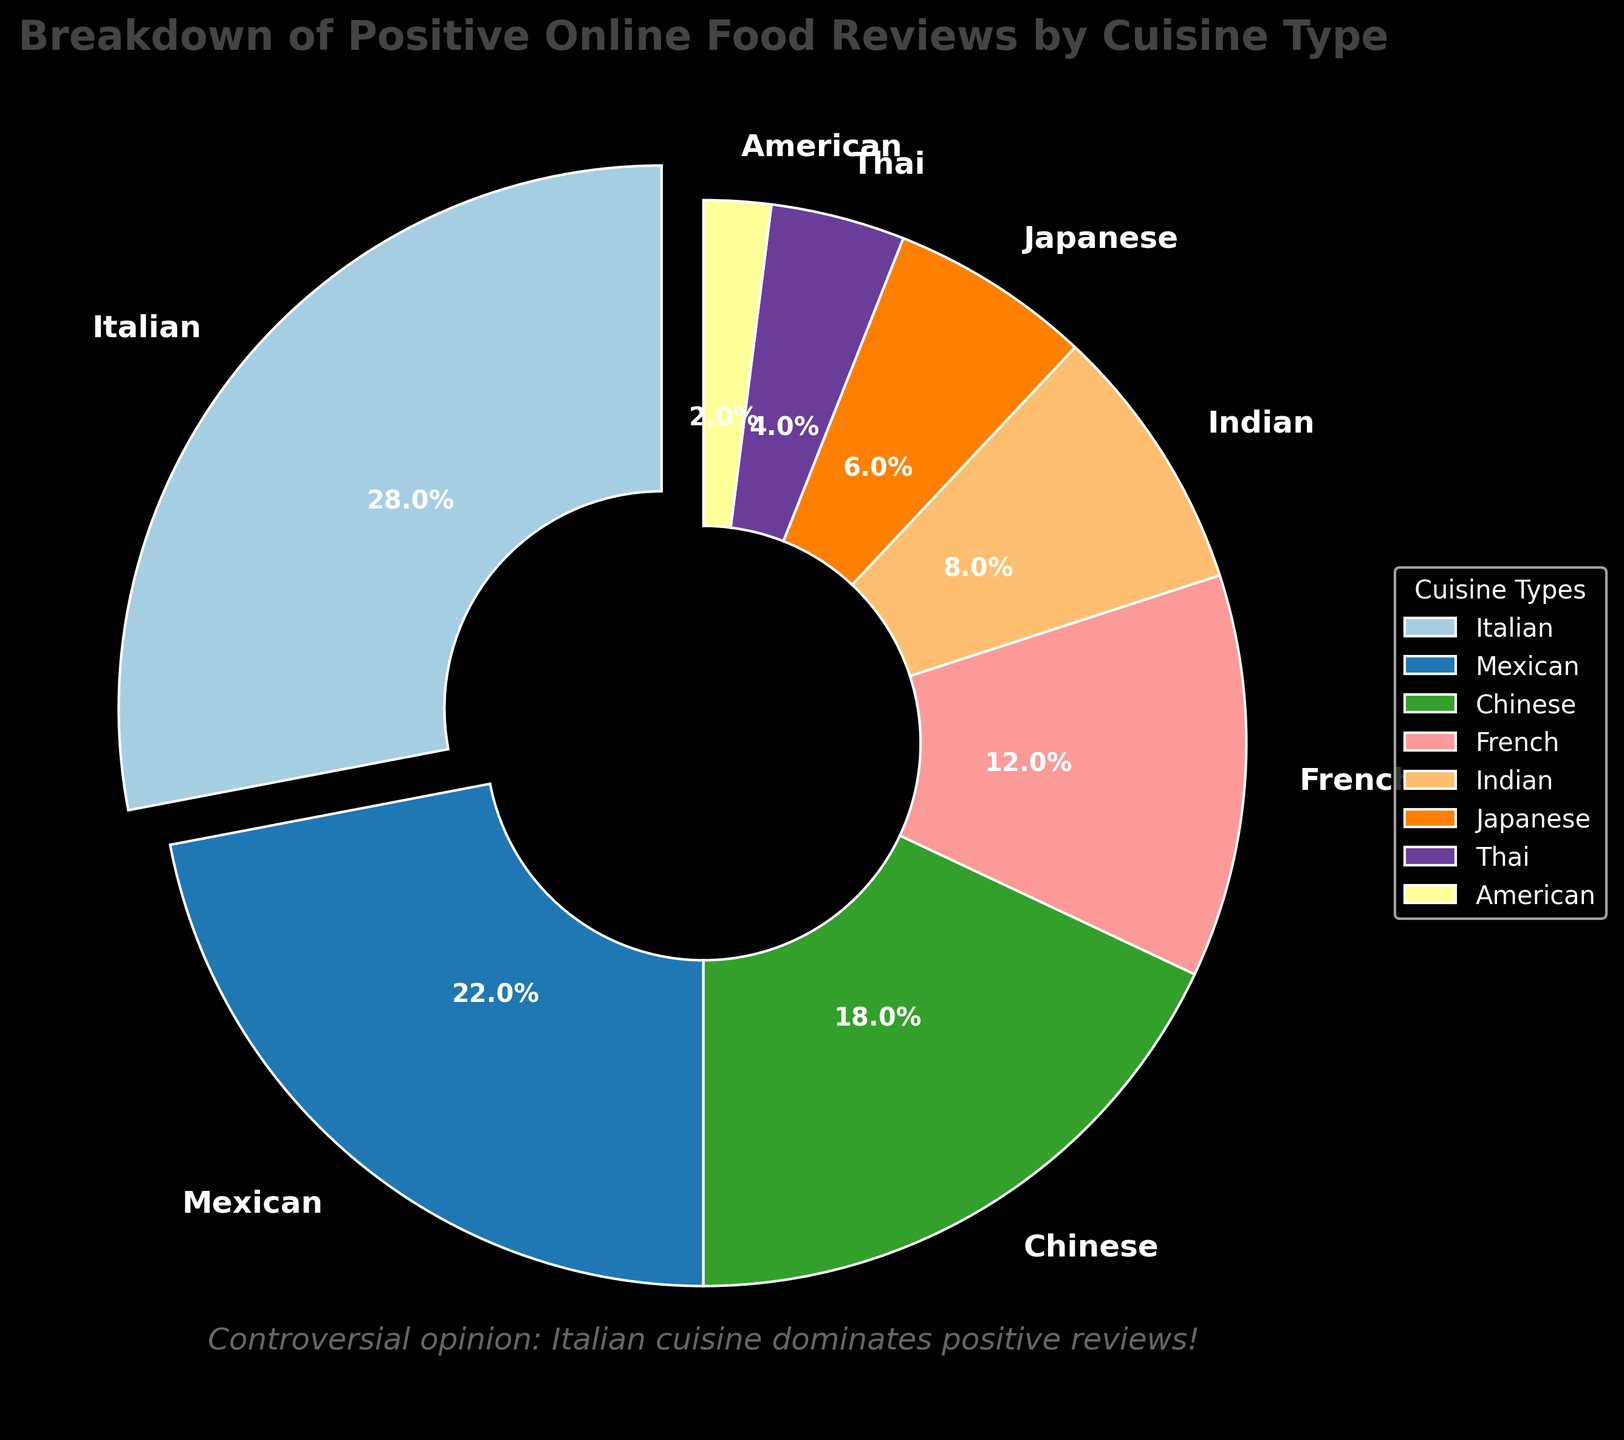Which cuisine has the highest percentage of positive reviews? The cuisine with the highest percentage is marked by an exploded wedge and annotated with the highest number. This is visually clear in the figure.
Answer: Italian Which cuisines have less than 10% of positive reviews each? To identify these cuisines, check the wedges with percentages less than 10% on the pie chart. The annotations show the percentages clearly.
Answer: Indian, Japanese, Thai, American What is the combined percentage of positive reviews for Mexican and Chinese cuisines? Add the percentages for Mexican (22%) and Chinese (18%) cuisines. 22 + 18 = 40.
Answer: 40% How much more is the percentage of positive reviews for Italian cuisine compared to French cuisine? Subtract the percentage for French (12%) from the percentage for Italian (28%). 28 - 12 = 16.
Answer: 16% Which cuisine has the smallest percentage of positive reviews and what is it? The smallest wedge with the smallest percentage annotation corresponds to the cuisine with the least positive reviews.
Answer: American, 2% Rank the cuisines from most to least positive reviews. Arrange the cuisines by descending order of their percentages as shown on the chart.
Answer: Italian, Mexican, Chinese, French, Indian, Japanese, Thai, American What percentage of positive reviews do the bottom three cuisines combined (Japanese, Thai, American) have? Add the percentages of Japanese (6%), Thai (4%), and American (2%). 6 + 4 + 2 = 12.
Answer: 12% Compare the combined percentage of positive reviews for Indian and Japanese cuisines with that of French cuisine. First, sum Indian (8%) and Japanese (6%) reviews. 8 + 6 = 14. Then, compare with French (12%) to see that 14 is greater than 12.
Answer: Indian and Japanese together have more positive reviews than French Is there any cuisine with exactly double the percentage of another cuisine's positive reviews? Compare pairs of percentages to see if any one value is exactly double another. Mexican (22%) is not exactly double any value, but French (12%) is exactly double American (6%).
Answer: No 